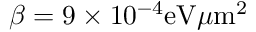<formula> <loc_0><loc_0><loc_500><loc_500>\beta = 9 \times 1 0 ^ { - 4 } e V \mu m ^ { 2 }</formula> 